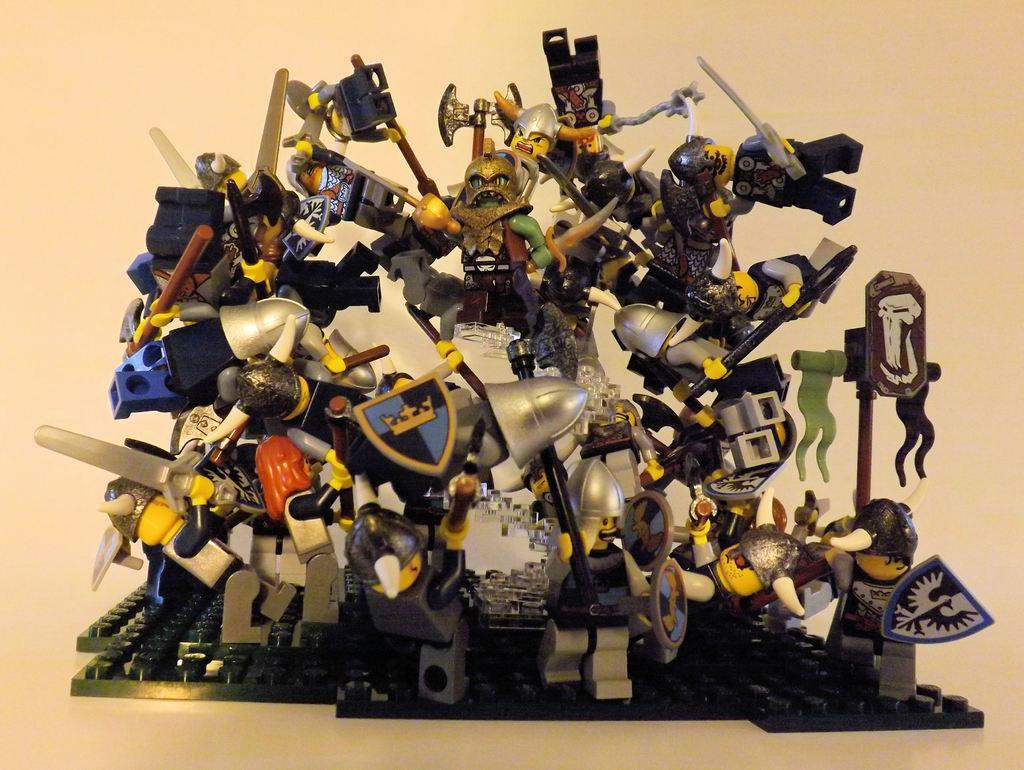What is located in the center of the image? There are toys and legos in the center of the image. Can you describe the toys in the image? The toys in the image include legos. What is visible in the background of the image? There is a wall in the background of the image. What type of pump is being used by the grandmother in the image? There is no grandmother or pump present in the image. What type of relation do the legos have with the toys in the image? The legos are a type of toy in the image, so they are related as different types of toys. 